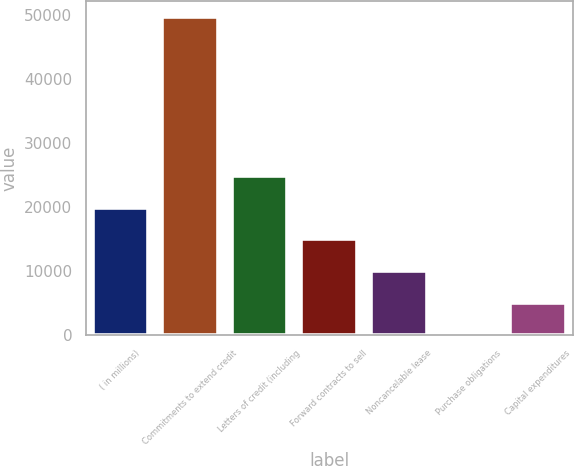Convert chart. <chart><loc_0><loc_0><loc_500><loc_500><bar_chart><fcel>( in millions)<fcel>Commitments to extend credit<fcel>Letters of credit (including<fcel>Forward contracts to sell<fcel>Noncancelable lease<fcel>Purchase obligations<fcel>Capital expenditures<nl><fcel>19946.4<fcel>49788<fcel>24920<fcel>14972.8<fcel>9999.2<fcel>52<fcel>5025.6<nl></chart> 